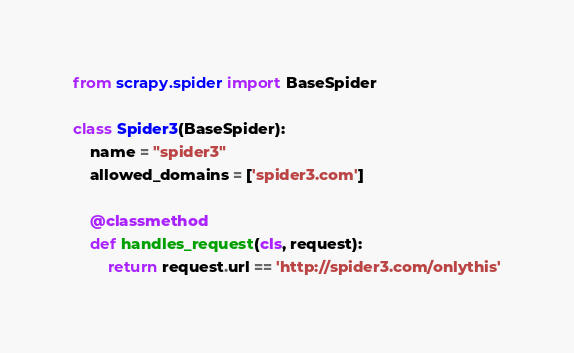<code> <loc_0><loc_0><loc_500><loc_500><_Python_>from scrapy.spider import BaseSpider

class Spider3(BaseSpider):
    name = "spider3"
    allowed_domains = ['spider3.com']

    @classmethod
    def handles_request(cls, request):
        return request.url == 'http://spider3.com/onlythis'
</code> 